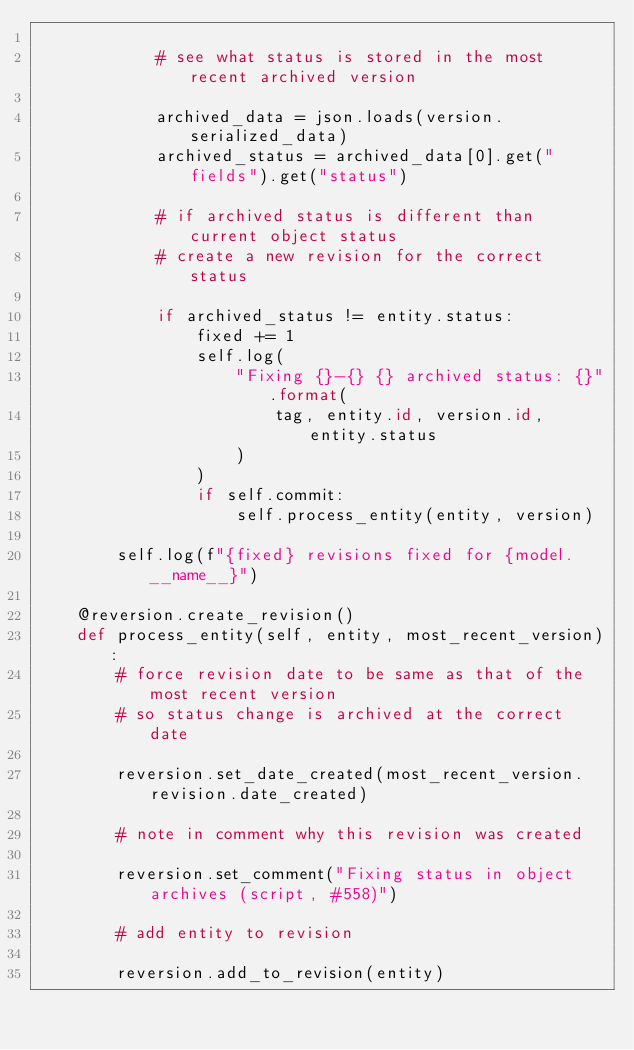<code> <loc_0><loc_0><loc_500><loc_500><_Python_>
            # see what status is stored in the most recent archived version

            archived_data = json.loads(version.serialized_data)
            archived_status = archived_data[0].get("fields").get("status")

            # if archived status is different than current object status
            # create a new revision for the correct status

            if archived_status != entity.status:
                fixed += 1
                self.log(
                    "Fixing {}-{} {} archived status: {}".format(
                        tag, entity.id, version.id, entity.status
                    )
                )
                if self.commit:
                    self.process_entity(entity, version)

        self.log(f"{fixed} revisions fixed for {model.__name__}")

    @reversion.create_revision()
    def process_entity(self, entity, most_recent_version):
        # force revision date to be same as that of the most recent version
        # so status change is archived at the correct date

        reversion.set_date_created(most_recent_version.revision.date_created)

        # note in comment why this revision was created

        reversion.set_comment("Fixing status in object archives (script, #558)")

        # add entity to revision

        reversion.add_to_revision(entity)
</code> 